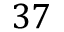<formula> <loc_0><loc_0><loc_500><loc_500>3 7</formula> 